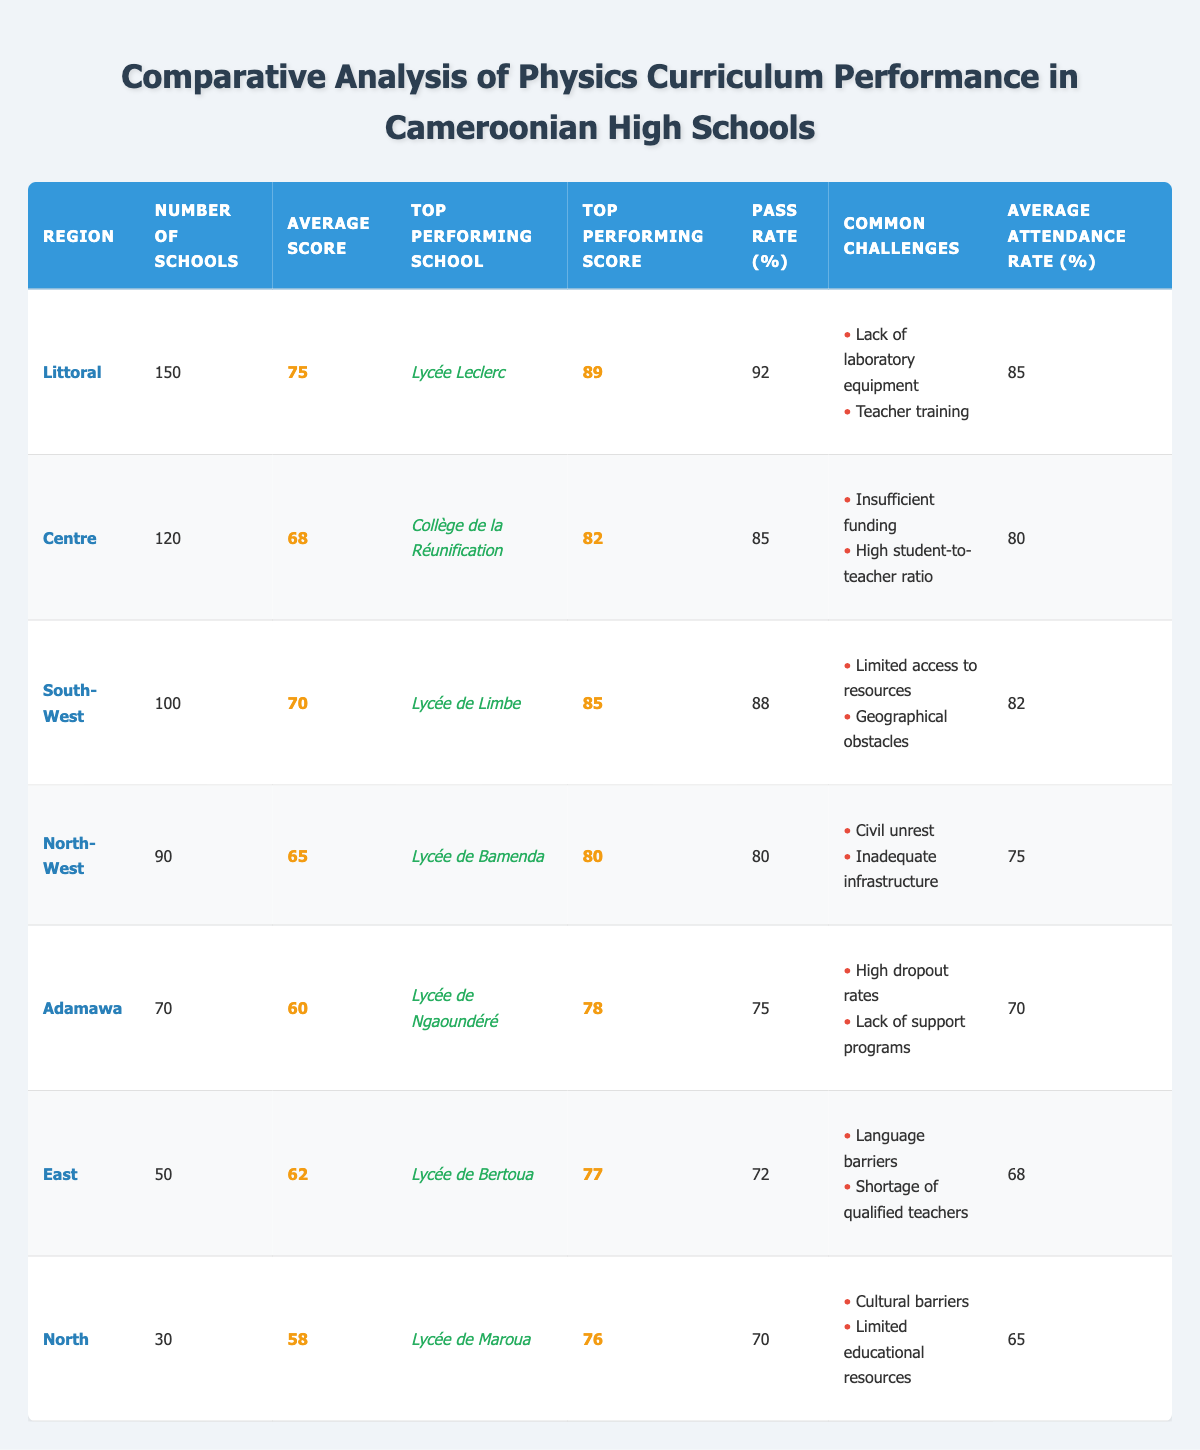What is the average score for the Littoral region? The table directly states that the average score for the Littoral region is 75.
Answer: 75 Which region has the highest pass rate? The Littoral region has the highest pass rate listed in the table at 92%.
Answer: 92% What is the top-performing school in the Centre region? The top-performing school in the Centre region is Collège de la Réunification, as indicated in the table.
Answer: Collège de la Réunification What are the common challenges faced by schools in the North-West region? The common challenges listed for the North-West region are civil unrest and inadequate infrastructure, as presented in the table.
Answer: Civil unrest and inadequate infrastructure Which region has the lowest average attendance rate? By comparing the average attendance rates in the table, the North region has the lowest at 65%.
Answer: 65% Calculate the average score for the Adamawa and East regions combined. The average score for Adamawa (60) and East (62) is calculated as (60 + 62) / 2 = 61.
Answer: 61 Is the average score of the South-West region higher than that of East? The South-West region has an average score of 70, while East has 62, so yes, 70 is higher than 62.
Answer: Yes What is the difference in the number of schools between the Littoral and North regions? The difference in the number of schools is calculated as 150 (Littoral) - 30 (North) = 120.
Answer: 120 Which region has the highest top-performing score? The highest top-performing score in the table is 89 from the Littoral region (Lycée Leclerc).
Answer: 89 If you combine the pass rates of the Littoral and Centre regions, what would be the total? The combined pass rates would be 92% (Littoral) + 85% (Centre) = 177%.
Answer: 177% 